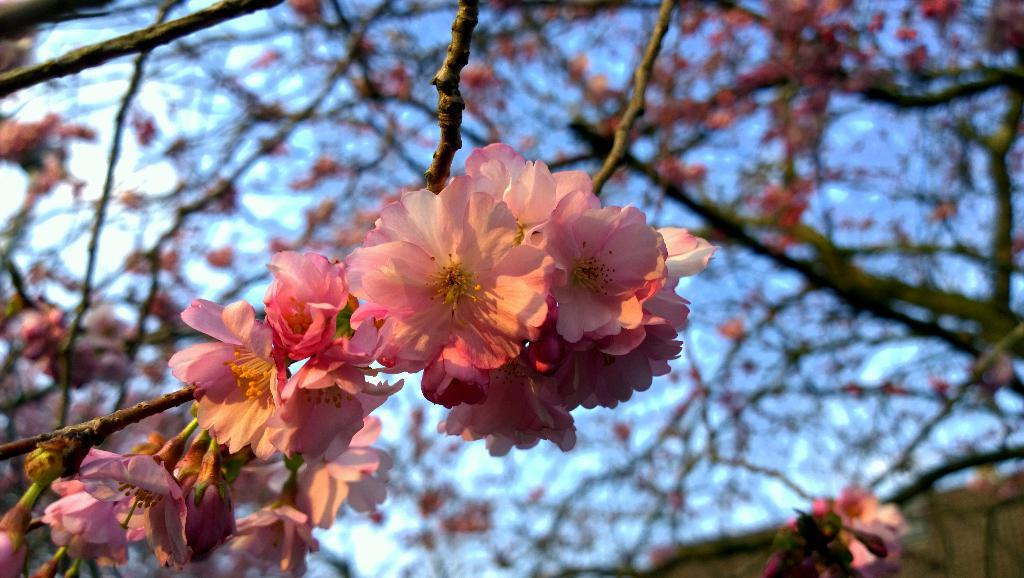What type of plants can be seen in the image? There are flowers in the image. What part of the flowers is visible in the image? There are stems in the image. Can you describe the background of the image? The background of the image is blurred. How many cacti can be seen in the image? There are no cacti present in the image; it features flowers and stems. What type of collar is visible on the flowers in the image? There is no collar present on the flowers in the image; they are natural flowers with stems. 